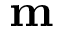<formula> <loc_0><loc_0><loc_500><loc_500>m</formula> 